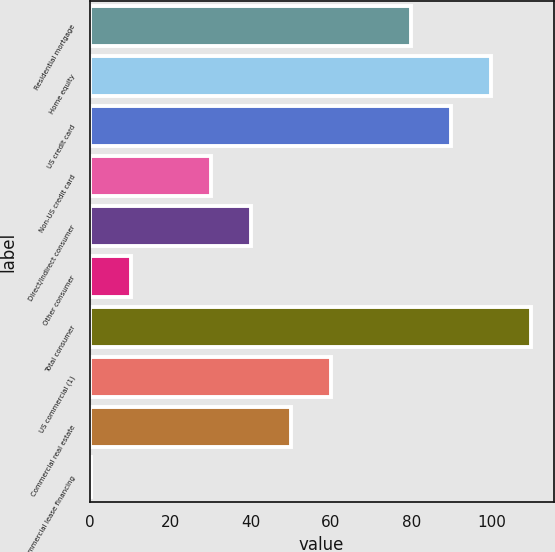<chart> <loc_0><loc_0><loc_500><loc_500><bar_chart><fcel>Residential mortgage<fcel>Home equity<fcel>US credit card<fcel>Non-US credit card<fcel>Direct/Indirect consumer<fcel>Other consumer<fcel>Total consumer<fcel>US commercial (1)<fcel>Commercial real estate<fcel>Commercial lease financing<nl><fcel>80.03<fcel>99.97<fcel>90<fcel>30.18<fcel>40.15<fcel>10.24<fcel>109.94<fcel>60.09<fcel>50.12<fcel>0.27<nl></chart> 